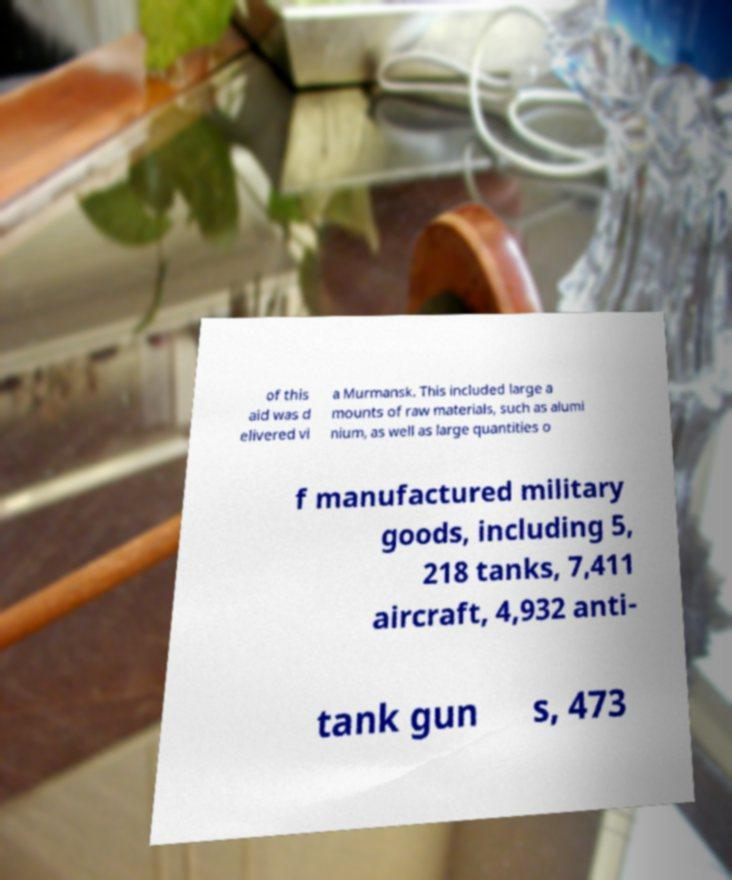There's text embedded in this image that I need extracted. Can you transcribe it verbatim? of this aid was d elivered vi a Murmansk. This included large a mounts of raw materials, such as alumi nium, as well as large quantities o f manufactured military goods, including 5, 218 tanks, 7,411 aircraft, 4,932 anti- tank gun s, 473 